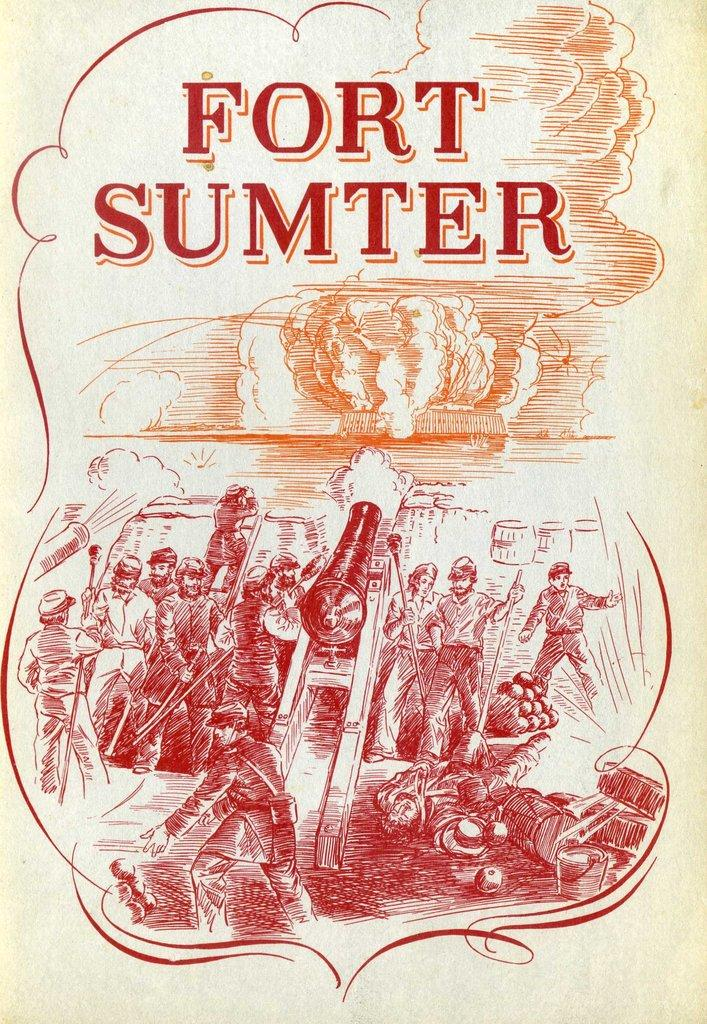<image>
Summarize the visual content of the image. A red and orange Fort Sumter sign for a book 